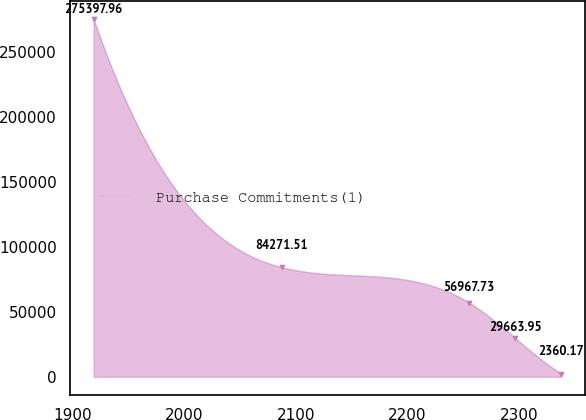Convert chart. <chart><loc_0><loc_0><loc_500><loc_500><line_chart><ecel><fcel>Purchase Commitments(1)<nl><fcel>1918.41<fcel>275398<nl><fcel>2087.33<fcel>84271.5<nl><fcel>2255.33<fcel>56967.7<nl><fcel>2296.62<fcel>29664<nl><fcel>2337.91<fcel>2360.17<nl></chart> 